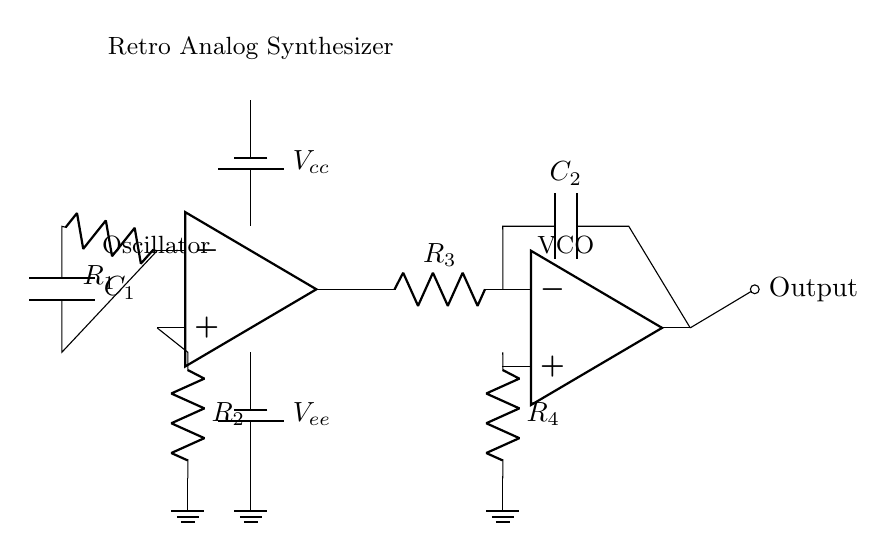What type of circuit is this? This circuit is an analog synthesizer. The presence of components like resistors, capacitors, and operational amplifiers indicates it is used to generate retro electronic sounds.
Answer: analog synthesizer What does R1 connect to? R1 connects to the non-inverting input of the operational amplifier (op amp). The schematic shows that one end of R1 is connected to the op amp's negative input terminal.
Answer: non-inverting input How many op amps are used? There are two operational amplifiers in the circuit, one for the oscillator and one for the voltage-controlled oscillator (VCO). Each is represented as a separate op amp symbol.
Answer: two What is the function of C1? The function of C1 is to couple signals in the oscillator circuit. Capacitors in these circuits are typically used for frequency modulation or filtering, and here it’s used to determine the oscillation frequency along with R1.
Answer: coupling signals What is the output labeled as? The output is labeled as "Output" on the circuit diagram. It denotes the point where the synthesized signal can be accessed.
Answer: Output How does the VCO receive input? The VCO receives input from the output of the first op amp (oscillator). This shows the signal flow from the oscillator to the VCO for further processing.
Answer: from the oscillator output 